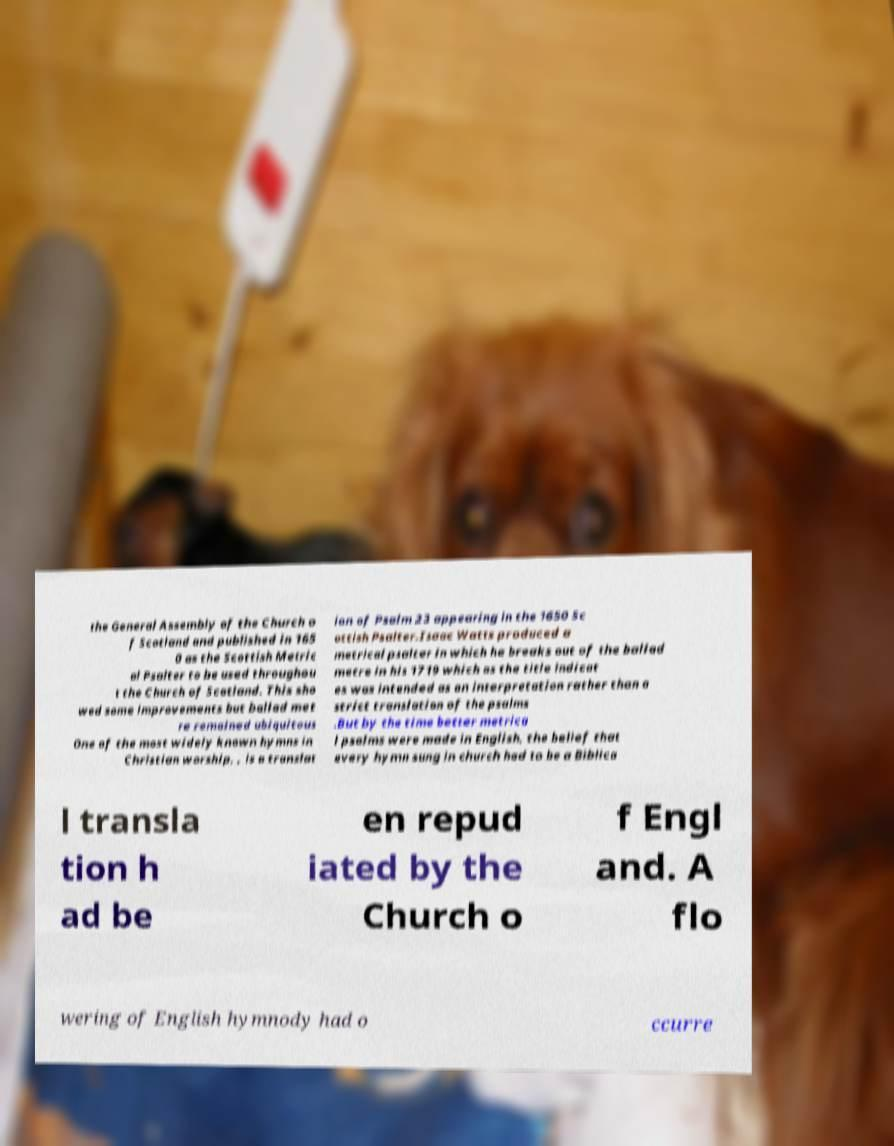For documentation purposes, I need the text within this image transcribed. Could you provide that? the General Assembly of the Church o f Scotland and published in 165 0 as the Scottish Metric al Psalter to be used throughou t the Church of Scotland. This sho wed some improvements but ballad met re remained ubiquitous One of the most widely known hymns in Christian worship, , is a translat ion of Psalm 23 appearing in the 1650 Sc ottish Psalter.Isaac Watts produced a metrical psalter in which he breaks out of the ballad metre in his 1719 which as the title indicat es was intended as an interpretation rather than a strict translation of the psalms .But by the time better metrica l psalms were made in English, the belief that every hymn sung in church had to be a Biblica l transla tion h ad be en repud iated by the Church o f Engl and. A flo wering of English hymnody had o ccurre 